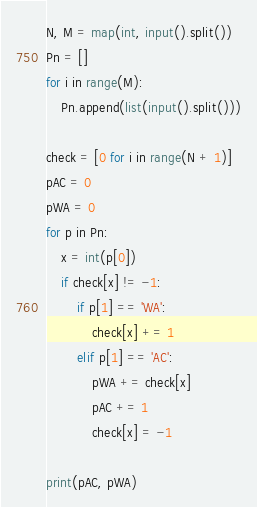<code> <loc_0><loc_0><loc_500><loc_500><_Python_>N, M = map(int, input().split())
Pn = []
for i in range(M):
    Pn.append(list(input().split()))

check = [0 for i in range(N + 1)]
pAC = 0
pWA = 0
for p in Pn:
    x = int(p[0])
    if check[x] != -1:
        if p[1] == 'WA':
            check[x] += 1
        elif p[1] == 'AC':
            pWA += check[x]
            pAC += 1
            check[x] = -1

print(pAC, pWA)
</code> 